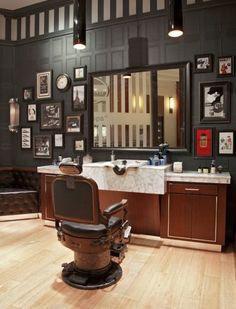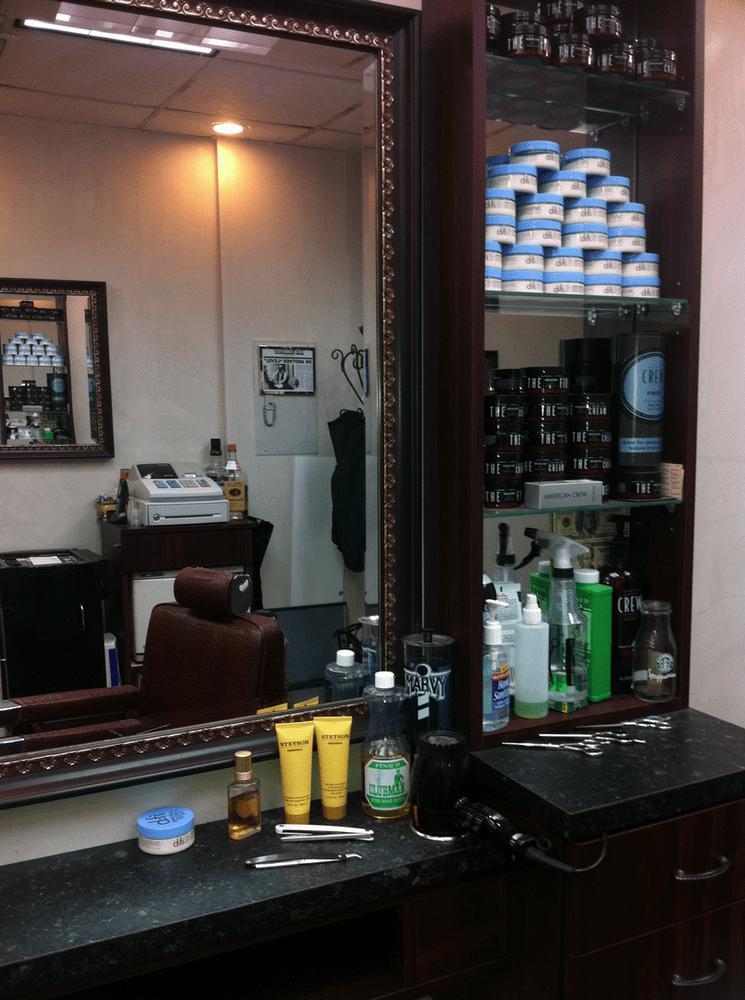The first image is the image on the left, the second image is the image on the right. Considering the images on both sides, is "One image has exactly two barber chairs." valid? Answer yes or no. No. The first image is the image on the left, the second image is the image on the right. Given the left and right images, does the statement "At least one of the images prominently features the storefront of a Barber Shop." hold true? Answer yes or no. No. 